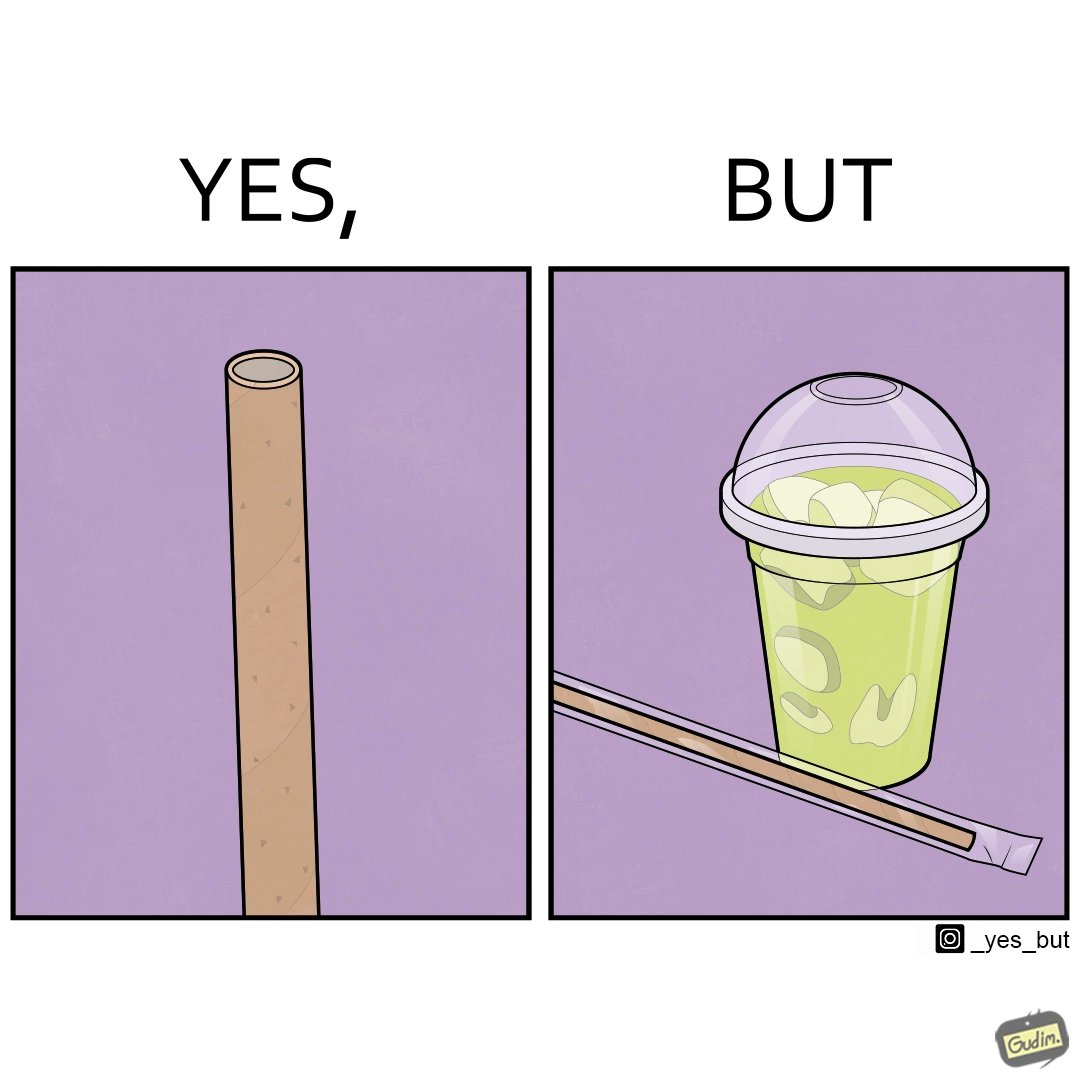What does this image depict? The images are ironic since paper straws were invented to reduce use of plastic in the form of plastic straws. However, these straws come in plastic packages and are served with plastic cups, defeating  the purpose 